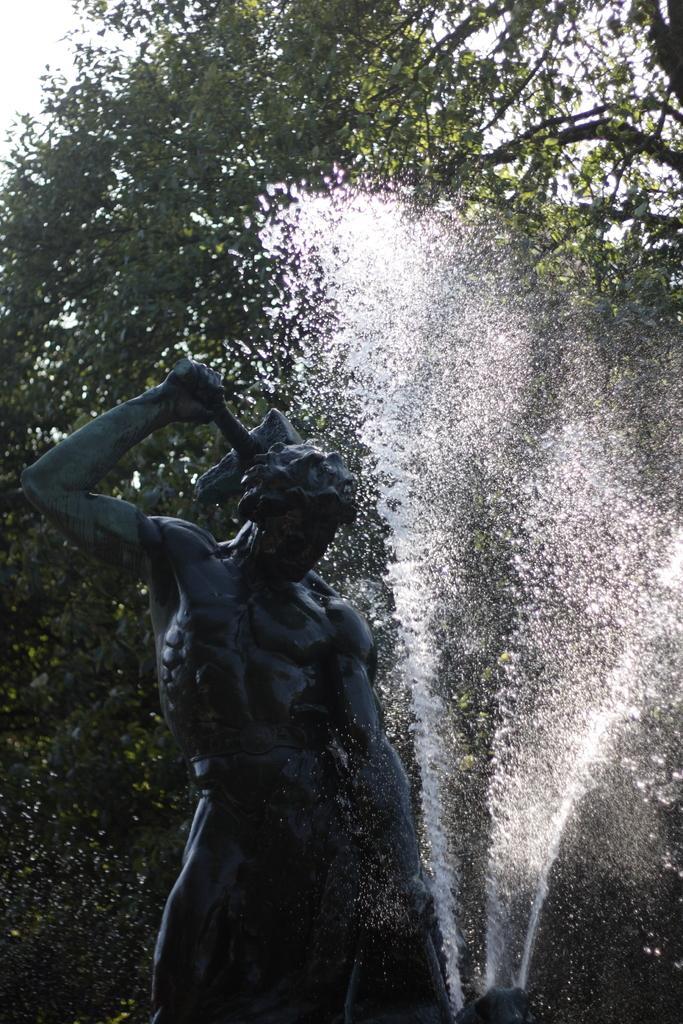How would you summarize this image in a sentence or two? In this picture we can see a statue of a person and in the background we can see water, trees, sky. 